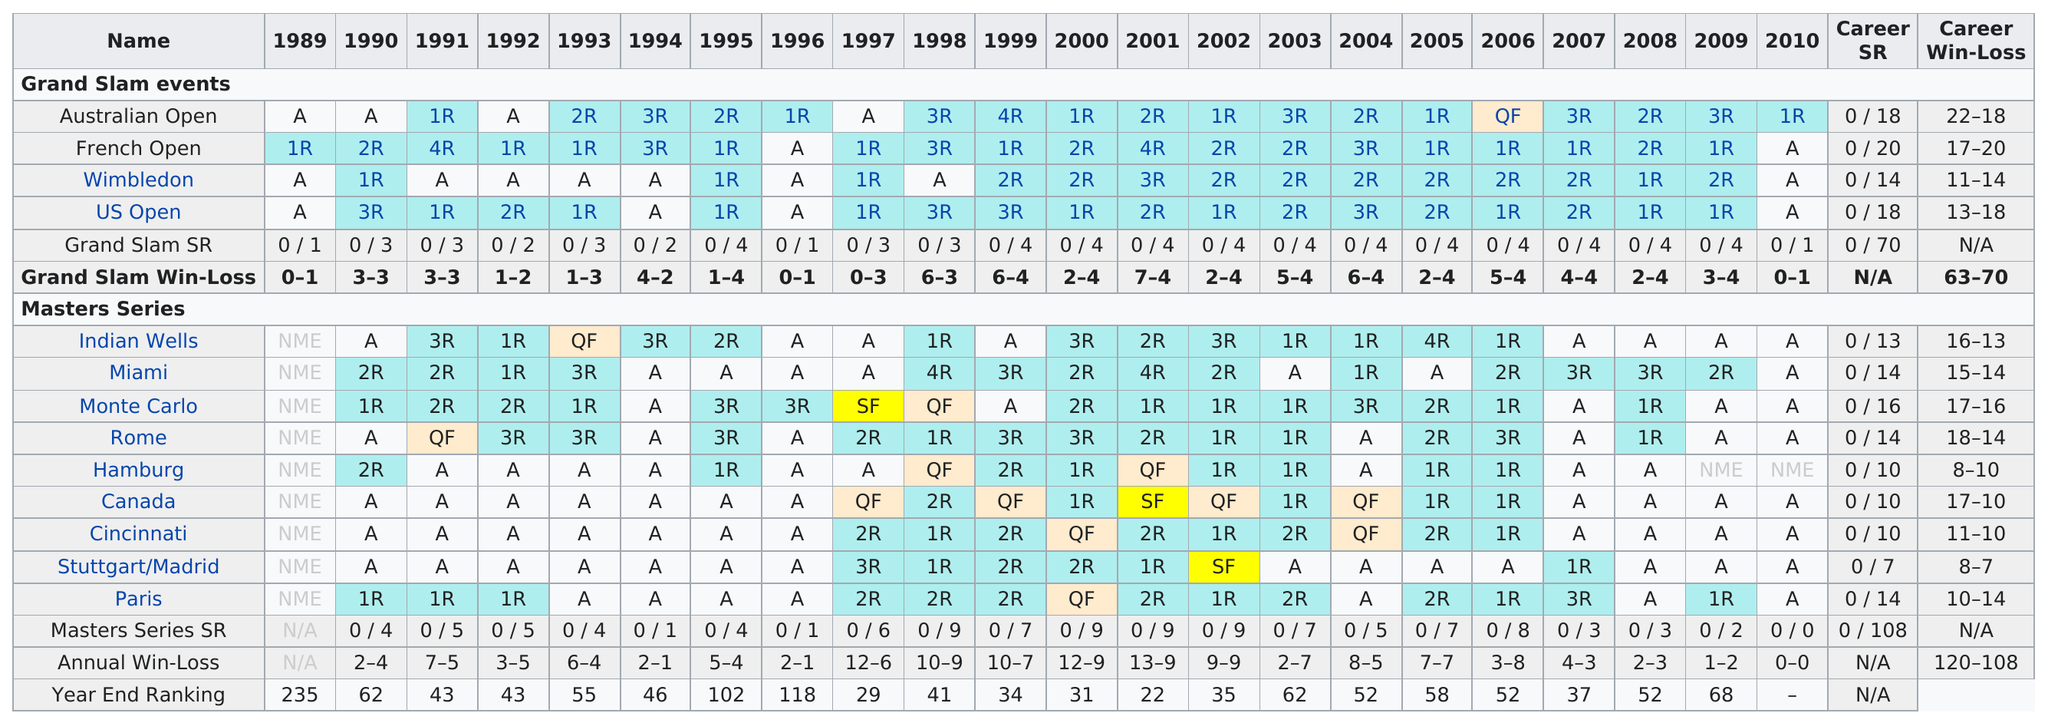Highlight a few significant elements in this photo. Fabrice Santoro achieved the only Grand Slam event where he reached as far as the quarterfinals, which was the Australian Open. There are four grand slam events. Roger Federer won more at the Australian Open than at the Indian Wells. There are only two grand slams besides Wimbledon and the US Open: the Australian Open and the French Open. Fabrice Santoro made his last Grand Slam appearance in 2010. 